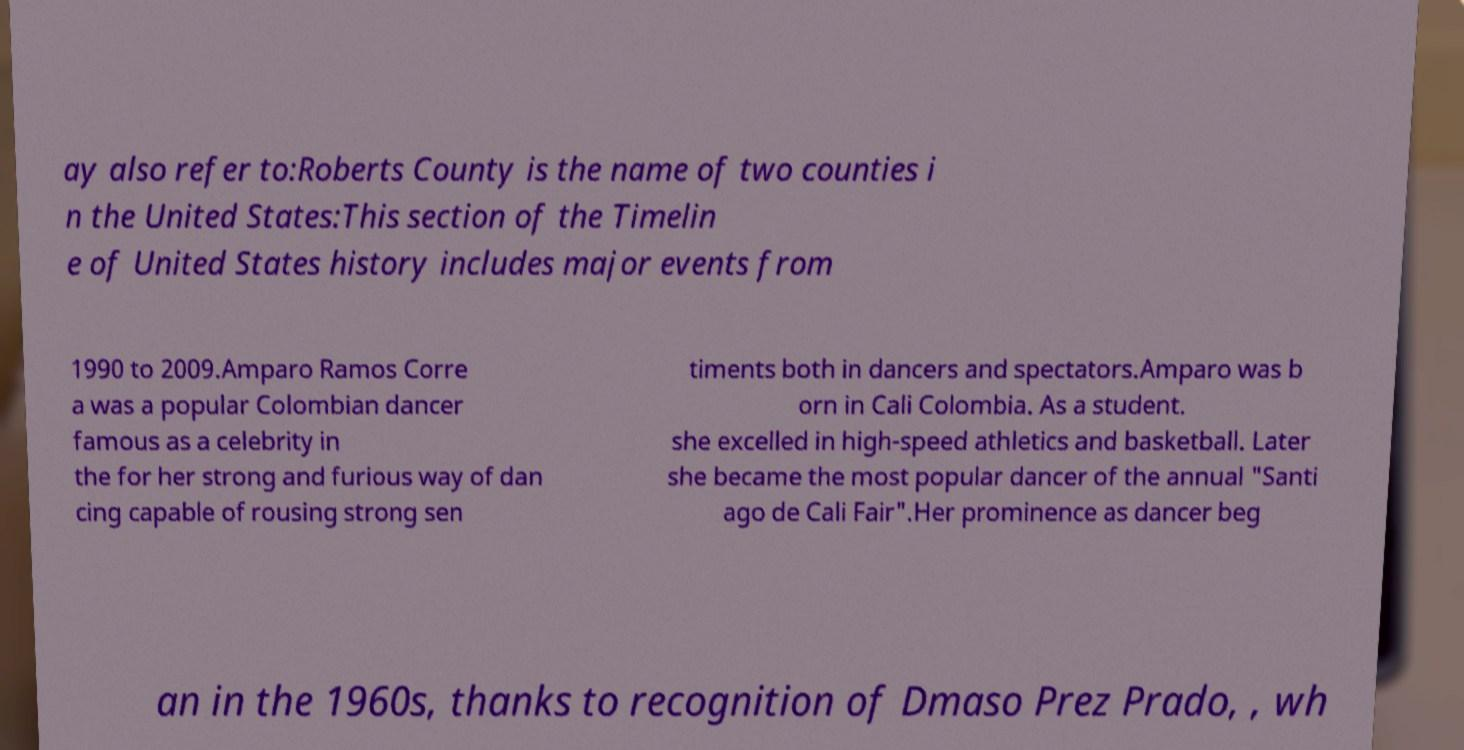Could you assist in decoding the text presented in this image and type it out clearly? ay also refer to:Roberts County is the name of two counties i n the United States:This section of the Timelin e of United States history includes major events from 1990 to 2009.Amparo Ramos Corre a was a popular Colombian dancer famous as a celebrity in the for her strong and furious way of dan cing capable of rousing strong sen timents both in dancers and spectators.Amparo was b orn in Cali Colombia. As a student. she excelled in high-speed athletics and basketball. Later she became the most popular dancer of the annual "Santi ago de Cali Fair".Her prominence as dancer beg an in the 1960s, thanks to recognition of Dmaso Prez Prado, , wh 